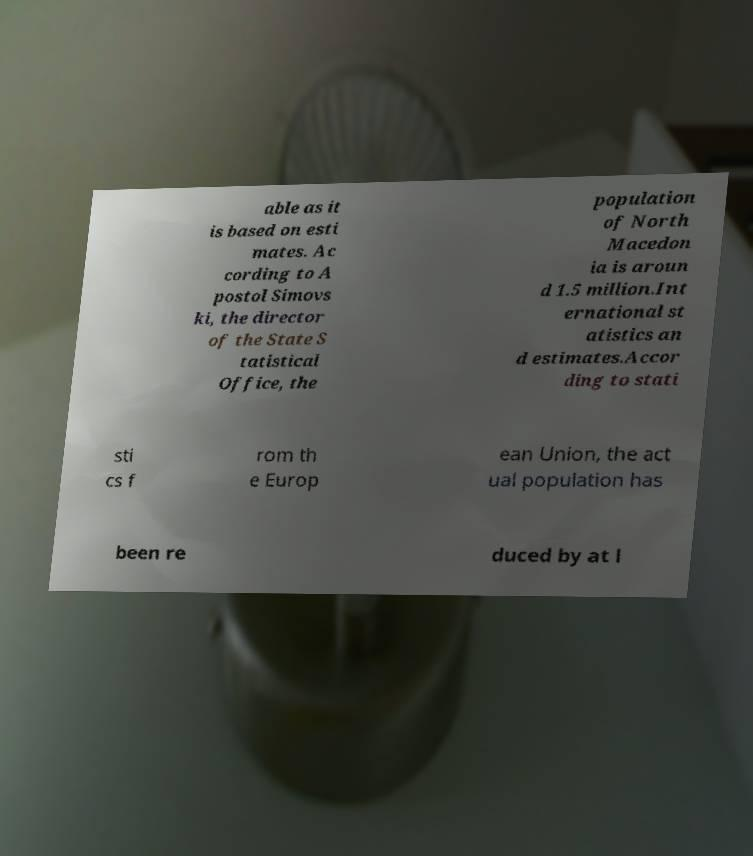Please read and relay the text visible in this image. What does it say? able as it is based on esti mates. Ac cording to A postol Simovs ki, the director of the State S tatistical Office, the population of North Macedon ia is aroun d 1.5 million.Int ernational st atistics an d estimates.Accor ding to stati sti cs f rom th e Europ ean Union, the act ual population has been re duced by at l 